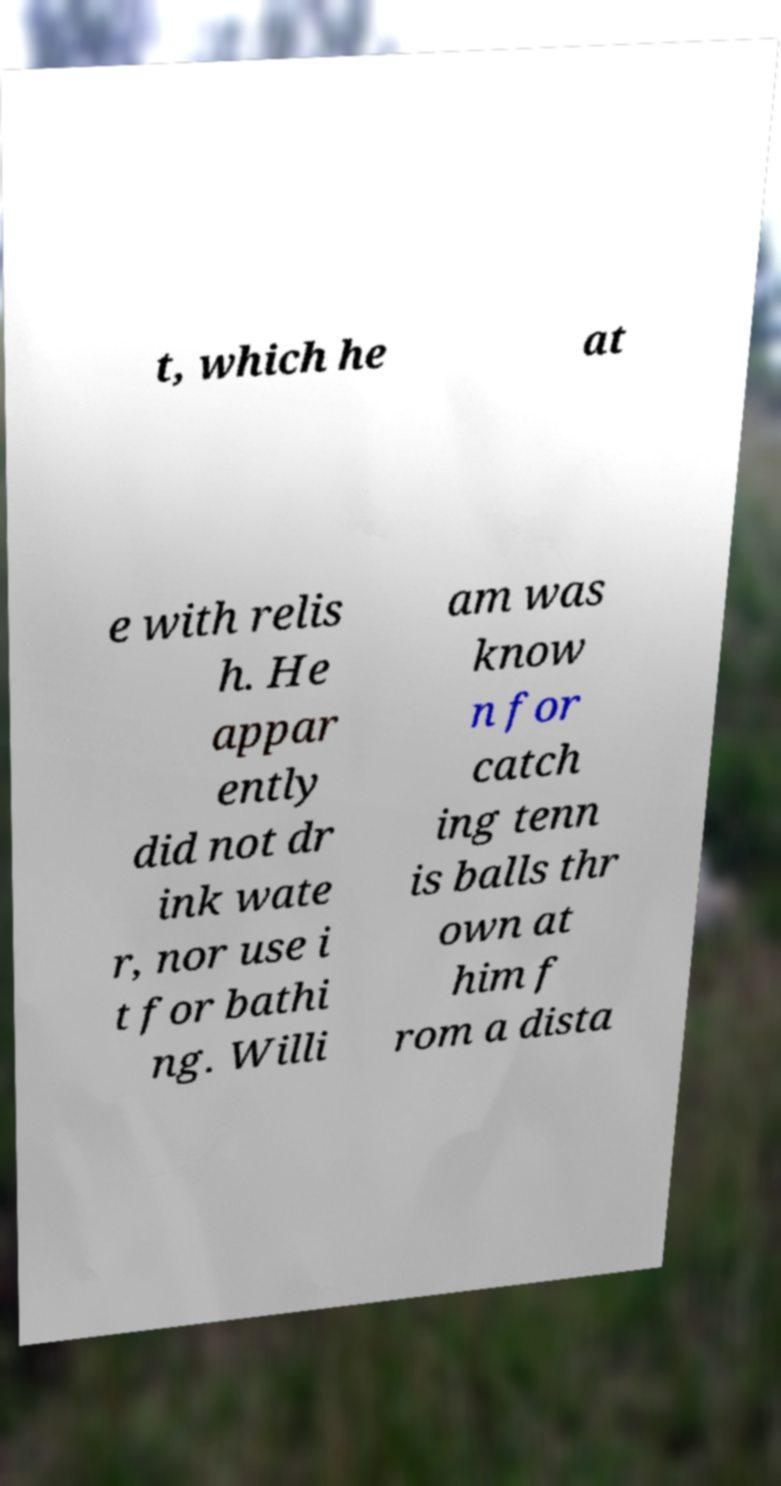Please read and relay the text visible in this image. What does it say? t, which he at e with relis h. He appar ently did not dr ink wate r, nor use i t for bathi ng. Willi am was know n for catch ing tenn is balls thr own at him f rom a dista 